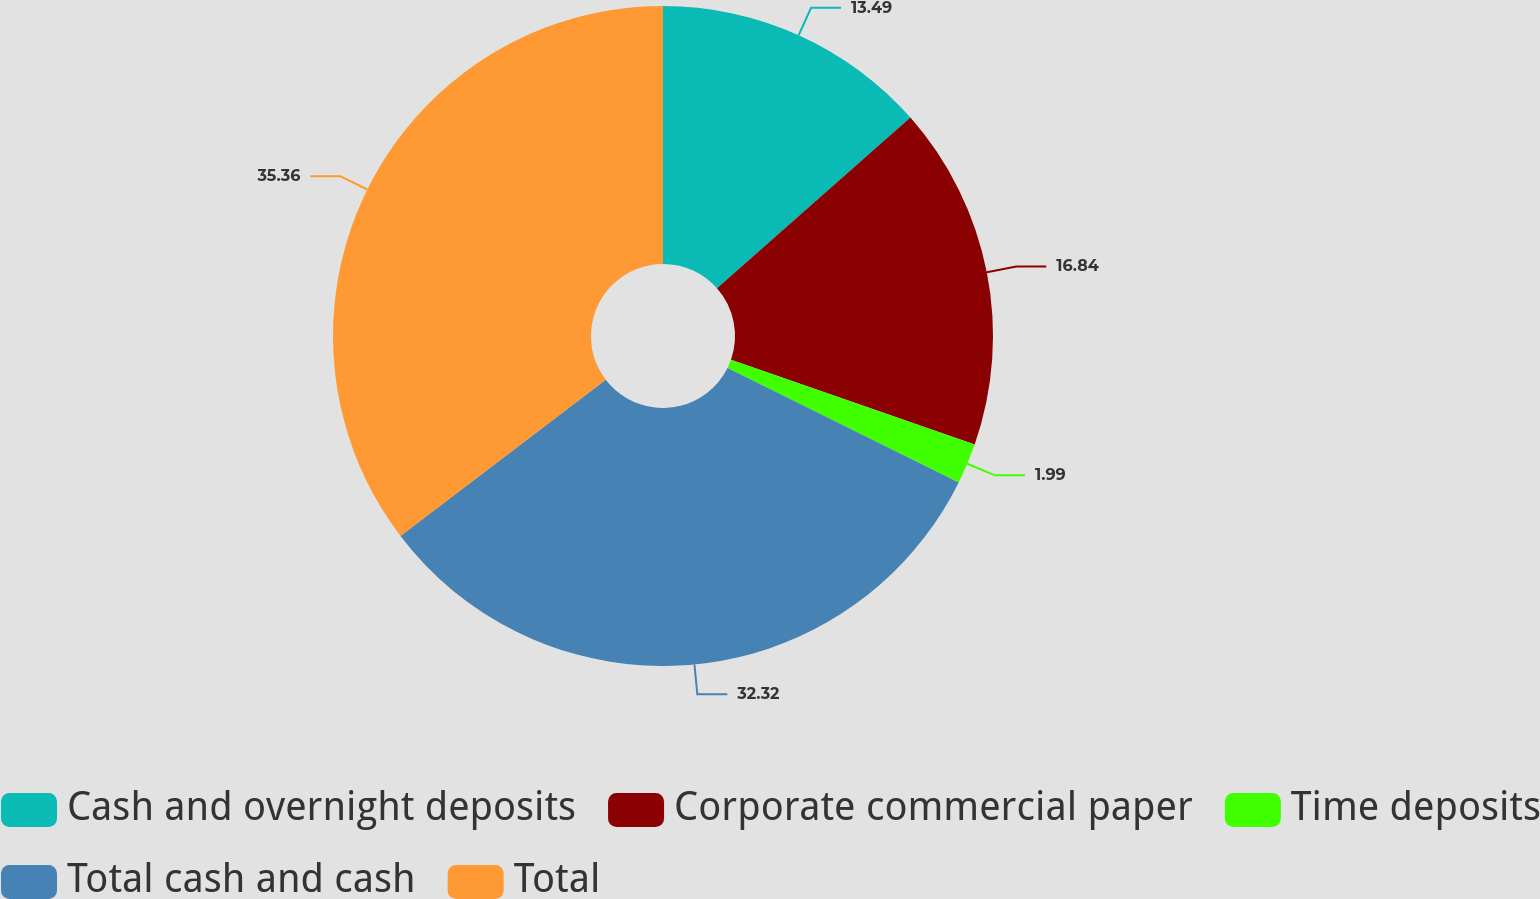Convert chart to OTSL. <chart><loc_0><loc_0><loc_500><loc_500><pie_chart><fcel>Cash and overnight deposits<fcel>Corporate commercial paper<fcel>Time deposits<fcel>Total cash and cash<fcel>Total<nl><fcel>13.49%<fcel>16.84%<fcel>1.99%<fcel>32.32%<fcel>35.36%<nl></chart> 